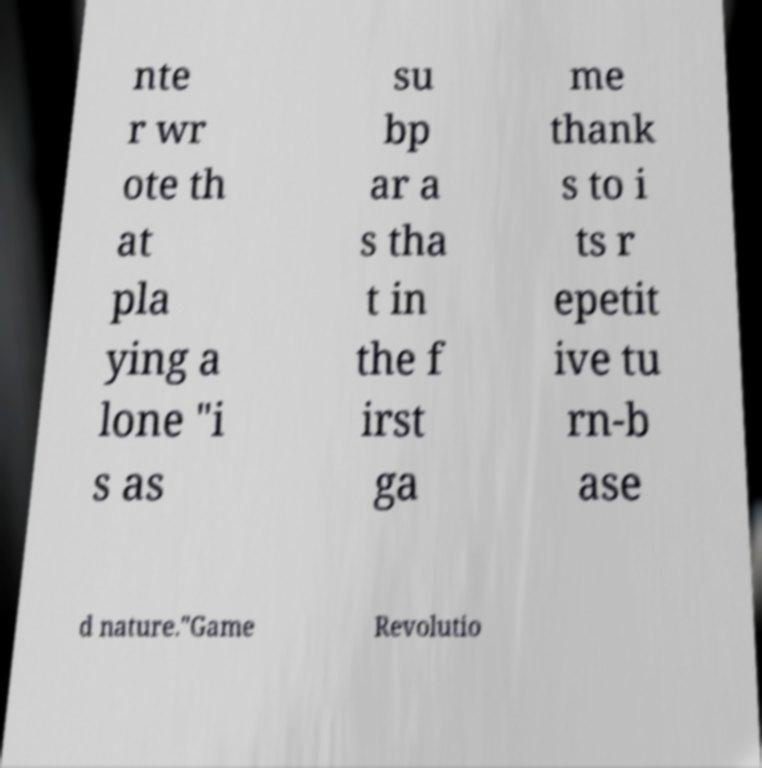Could you extract and type out the text from this image? nte r wr ote th at pla ying a lone "i s as su bp ar a s tha t in the f irst ga me thank s to i ts r epetit ive tu rn-b ase d nature."Game Revolutio 